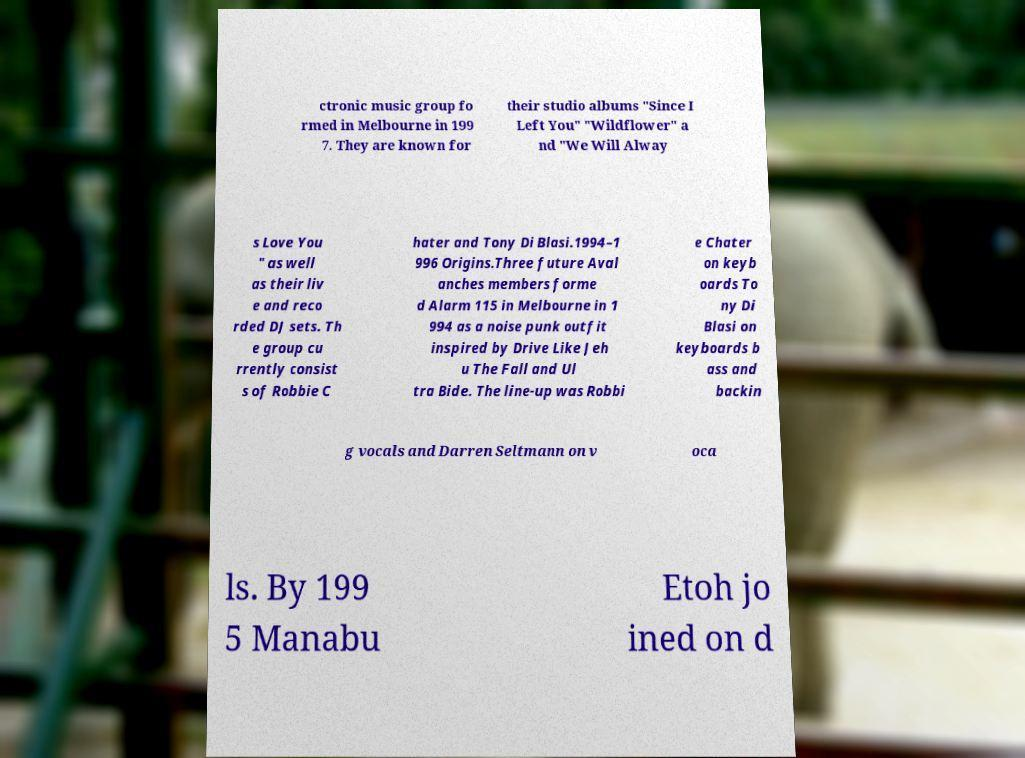I need the written content from this picture converted into text. Can you do that? ctronic music group fo rmed in Melbourne in 199 7. They are known for their studio albums "Since I Left You" "Wildflower" a nd "We Will Alway s Love You " as well as their liv e and reco rded DJ sets. Th e group cu rrently consist s of Robbie C hater and Tony Di Blasi.1994–1 996 Origins.Three future Aval anches members forme d Alarm 115 in Melbourne in 1 994 as a noise punk outfit inspired by Drive Like Jeh u The Fall and Ul tra Bide. The line-up was Robbi e Chater on keyb oards To ny Di Blasi on keyboards b ass and backin g vocals and Darren Seltmann on v oca ls. By 199 5 Manabu Etoh jo ined on d 